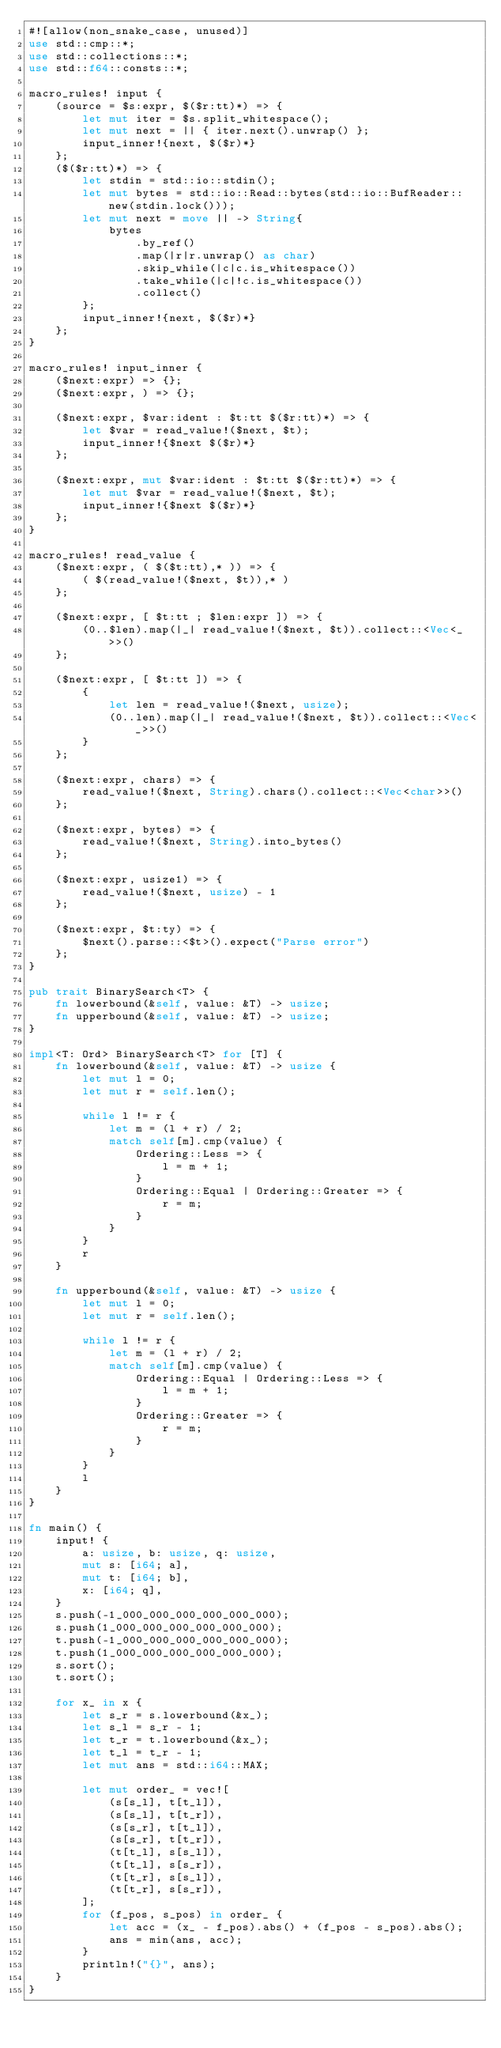<code> <loc_0><loc_0><loc_500><loc_500><_Rust_>#![allow(non_snake_case, unused)]
use std::cmp::*;
use std::collections::*;
use std::f64::consts::*;

macro_rules! input {
    (source = $s:expr, $($r:tt)*) => {
        let mut iter = $s.split_whitespace();
        let mut next = || { iter.next().unwrap() };
        input_inner!{next, $($r)*}
    };
    ($($r:tt)*) => {
        let stdin = std::io::stdin();
        let mut bytes = std::io::Read::bytes(std::io::BufReader::new(stdin.lock()));
        let mut next = move || -> String{
            bytes
                .by_ref()
                .map(|r|r.unwrap() as char)
                .skip_while(|c|c.is_whitespace())
                .take_while(|c|!c.is_whitespace())
                .collect()
        };
        input_inner!{next, $($r)*}
    };
}

macro_rules! input_inner {
    ($next:expr) => {};
    ($next:expr, ) => {};

    ($next:expr, $var:ident : $t:tt $($r:tt)*) => {
        let $var = read_value!($next, $t);
        input_inner!{$next $($r)*}
    };

    ($next:expr, mut $var:ident : $t:tt $($r:tt)*) => {
        let mut $var = read_value!($next, $t);
        input_inner!{$next $($r)*}
    };
}

macro_rules! read_value {
    ($next:expr, ( $($t:tt),* )) => {
        ( $(read_value!($next, $t)),* )
    };

    ($next:expr, [ $t:tt ; $len:expr ]) => {
        (0..$len).map(|_| read_value!($next, $t)).collect::<Vec<_>>()
    };

    ($next:expr, [ $t:tt ]) => {
        {
            let len = read_value!($next, usize);
            (0..len).map(|_| read_value!($next, $t)).collect::<Vec<_>>()
        }
    };

    ($next:expr, chars) => {
        read_value!($next, String).chars().collect::<Vec<char>>()
    };

    ($next:expr, bytes) => {
        read_value!($next, String).into_bytes()
    };

    ($next:expr, usize1) => {
        read_value!($next, usize) - 1
    };

    ($next:expr, $t:ty) => {
        $next().parse::<$t>().expect("Parse error")
    };
}

pub trait BinarySearch<T> {
    fn lowerbound(&self, value: &T) -> usize;
    fn upperbound(&self, value: &T) -> usize;
}

impl<T: Ord> BinarySearch<T> for [T] {
    fn lowerbound(&self, value: &T) -> usize {
        let mut l = 0;
        let mut r = self.len();

        while l != r {
            let m = (l + r) / 2;
            match self[m].cmp(value) {
                Ordering::Less => {
                    l = m + 1;
                }
                Ordering::Equal | Ordering::Greater => {
                    r = m;
                }
            }
        }
        r
    }

    fn upperbound(&self, value: &T) -> usize {
        let mut l = 0;
        let mut r = self.len();

        while l != r {
            let m = (l + r) / 2;
            match self[m].cmp(value) {
                Ordering::Equal | Ordering::Less => {
                    l = m + 1;
                }
                Ordering::Greater => {
                    r = m;
                }
            }
        }
        l
    }
}

fn main() {
    input! {
        a: usize, b: usize, q: usize,
        mut s: [i64; a],
        mut t: [i64; b],
        x: [i64; q],
    }
    s.push(-1_000_000_000_000_000_000);
    s.push(1_000_000_000_000_000_000);
    t.push(-1_000_000_000_000_000_000);
    t.push(1_000_000_000_000_000_000);
    s.sort();
    t.sort();

    for x_ in x {
        let s_r = s.lowerbound(&x_);
        let s_l = s_r - 1;
        let t_r = t.lowerbound(&x_);
        let t_l = t_r - 1;
        let mut ans = std::i64::MAX;

        let mut order_ = vec![
            (s[s_l], t[t_l]),
            (s[s_l], t[t_r]),
            (s[s_r], t[t_l]),
            (s[s_r], t[t_r]),
            (t[t_l], s[s_l]),
            (t[t_l], s[s_r]),
            (t[t_r], s[s_l]),
            (t[t_r], s[s_r]),
        ];
        for (f_pos, s_pos) in order_ {
            let acc = (x_ - f_pos).abs() + (f_pos - s_pos).abs();
            ans = min(ans, acc);
        }
        println!("{}", ans);
    }
}
</code> 